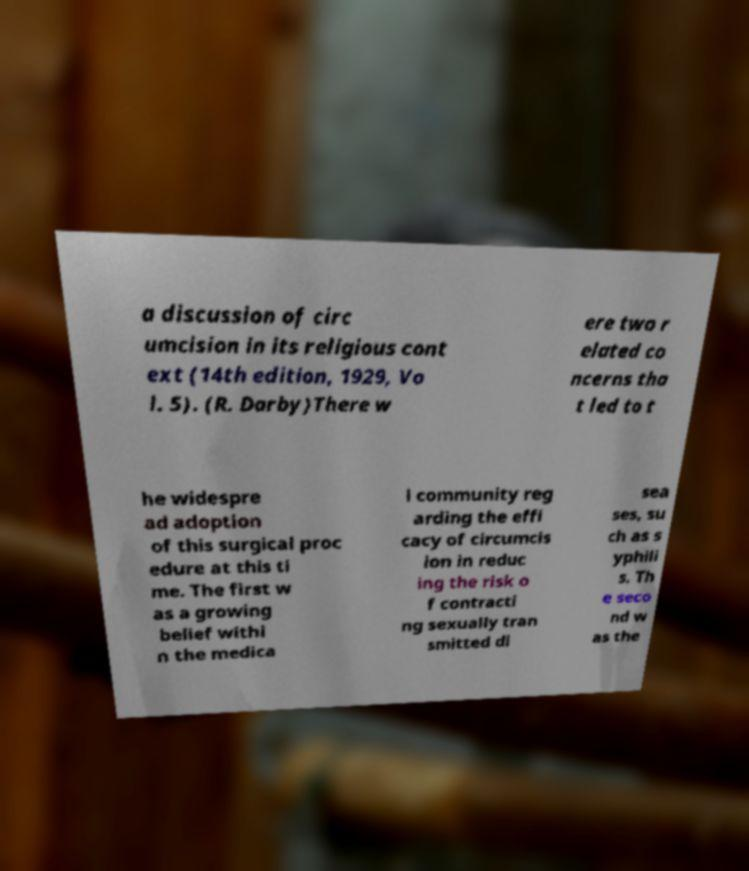I need the written content from this picture converted into text. Can you do that? a discussion of circ umcision in its religious cont ext (14th edition, 1929, Vo l. 5). (R. Darby)There w ere two r elated co ncerns tha t led to t he widespre ad adoption of this surgical proc edure at this ti me. The first w as a growing belief withi n the medica l community reg arding the effi cacy of circumcis ion in reduc ing the risk o f contracti ng sexually tran smitted di sea ses, su ch as s yphili s. Th e seco nd w as the 